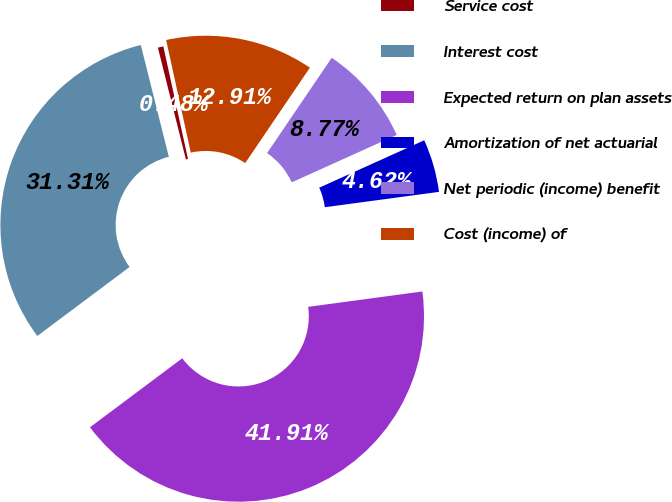<chart> <loc_0><loc_0><loc_500><loc_500><pie_chart><fcel>Service cost<fcel>Interest cost<fcel>Expected return on plan assets<fcel>Amortization of net actuarial<fcel>Net periodic (income) benefit<fcel>Cost (income) of<nl><fcel>0.48%<fcel>31.31%<fcel>41.91%<fcel>4.62%<fcel>8.77%<fcel>12.91%<nl></chart> 